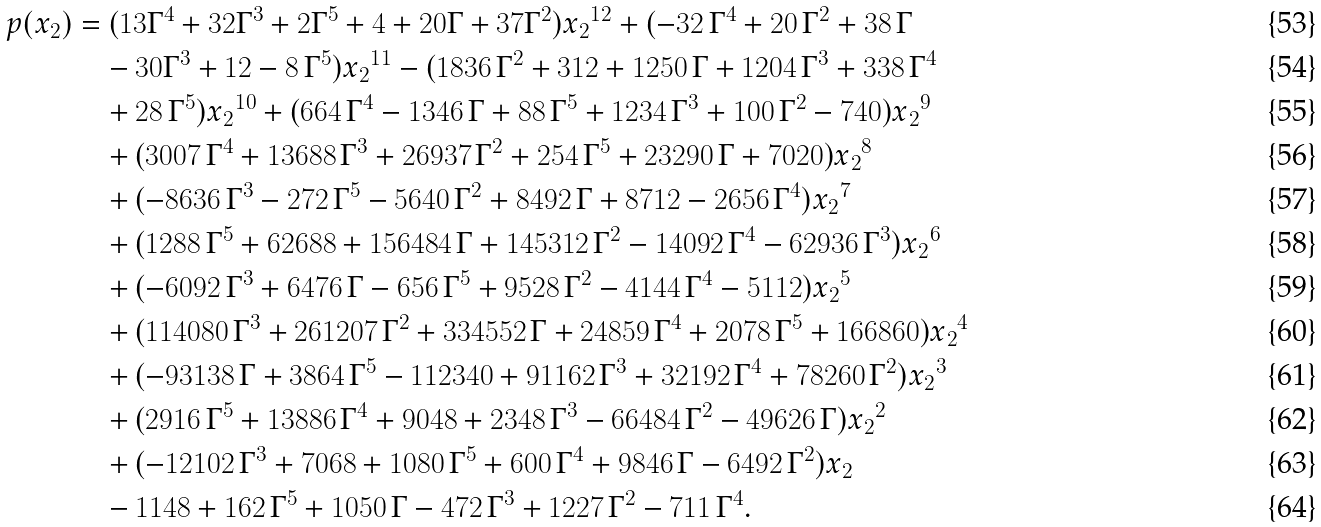Convert formula to latex. <formula><loc_0><loc_0><loc_500><loc_500>p ( x _ { 2 } ) & = ( 1 3 \Gamma ^ { 4 } + 3 2 \Gamma ^ { 3 } + 2 \Gamma ^ { 5 } + 4 + 2 0 \Gamma + 3 7 \Gamma ^ { 2 } ) { x _ { 2 } } ^ { 1 2 } + ( - 3 2 \, { \Gamma } ^ { 4 } + 2 0 \, { \Gamma } ^ { 2 } + 3 8 \, \Gamma \\ & \quad - 3 0 { \Gamma } ^ { 3 } + 1 2 - 8 \, { \Gamma } ^ { 5 } ) { x _ { 2 } } ^ { 1 1 } - ( 1 8 3 6 \, { \Gamma } ^ { 2 } + 3 1 2 + 1 2 5 0 \, \Gamma + 1 2 0 4 \, { \Gamma } ^ { 3 } + 3 3 8 \, { \Gamma } ^ { 4 } \\ & \quad + 2 8 \, { \Gamma } ^ { 5 } ) { x _ { 2 } } ^ { 1 0 } + ( 6 6 4 \, { \Gamma } ^ { 4 } - 1 3 4 6 \, \Gamma + 8 8 \, { \Gamma } ^ { 5 } + 1 2 3 4 \, { \Gamma } ^ { 3 } + 1 0 0 \, { \Gamma } ^ { 2 } - 7 4 0 ) { x _ { 2 } } ^ { 9 } \\ & \quad + ( 3 0 0 7 \, { \Gamma } ^ { 4 } + 1 3 6 8 8 \, { \Gamma } ^ { 3 } + 2 6 9 3 7 \, { \Gamma } ^ { 2 } + 2 5 4 \, { \Gamma } ^ { 5 } + 2 3 2 9 0 \, \Gamma + 7 0 2 0 ) { x _ { 2 } } ^ { 8 } \\ & \quad + ( - 8 6 3 6 \, { \Gamma } ^ { 3 } - 2 7 2 \, { \Gamma } ^ { 5 } - 5 6 4 0 \, { \Gamma } ^ { 2 } + 8 4 9 2 \, \Gamma + 8 7 1 2 - 2 6 5 6 \, { \Gamma } ^ { 4 } ) { x _ { 2 } } ^ { 7 } \\ & \quad + ( 1 2 8 8 \, { \Gamma } ^ { 5 } + 6 2 6 8 8 + 1 5 6 4 8 4 \, \Gamma + 1 4 5 3 1 2 \, { \Gamma } ^ { 2 } - 1 4 0 9 2 \, { \Gamma } ^ { 4 } - 6 2 9 3 6 \, { \Gamma } ^ { 3 } ) { x _ { 2 } } ^ { 6 } \\ & \quad + ( - 6 0 9 2 \, { \Gamma } ^ { 3 } + 6 4 7 6 \, \Gamma - 6 5 6 \, { \Gamma } ^ { 5 } + 9 5 2 8 \, { \Gamma } ^ { 2 } - 4 1 4 4 \, { \Gamma } ^ { 4 } - 5 1 1 2 ) { x _ { 2 } } ^ { 5 } \\ & \quad + ( 1 1 4 0 8 0 \, { \Gamma } ^ { 3 } + 2 6 1 2 0 7 \, { \Gamma } ^ { 2 } + 3 3 4 5 5 2 \, \Gamma + 2 4 8 5 9 \, { \Gamma } ^ { 4 } + 2 0 7 8 \, { \Gamma } ^ { 5 } + 1 6 6 8 6 0 ) { x _ { 2 } } ^ { 4 } \\ & \quad + ( - 9 3 1 3 8 \, \Gamma + 3 8 6 4 \, { \Gamma } ^ { 5 } - 1 1 2 3 4 0 + 9 1 1 6 2 \, { \Gamma } ^ { 3 } + 3 2 1 9 2 \, { \Gamma } ^ { 4 } + 7 8 2 6 0 \, { \Gamma } ^ { 2 } ) { x _ { 2 } } ^ { 3 } \\ & \quad + ( 2 9 1 6 \, { \Gamma } ^ { 5 } + 1 3 8 8 6 \, { \Gamma } ^ { 4 } + 9 0 4 8 + 2 3 4 8 \, { \Gamma } ^ { 3 } - 6 6 4 8 4 \, { \Gamma } ^ { 2 } - 4 9 6 2 6 \, \Gamma ) { x _ { 2 } } ^ { 2 } \\ & \quad + ( - 1 2 1 0 2 \, { \Gamma } ^ { 3 } + 7 0 6 8 + 1 0 8 0 \, { \Gamma } ^ { 5 } + 6 0 0 \, { \Gamma } ^ { 4 } + 9 8 4 6 \, \Gamma - 6 4 9 2 \, { \Gamma } ^ { 2 } ) { x _ { 2 } } \\ & \quad - 1 1 4 8 + 1 6 2 \, { \Gamma } ^ { 5 } + 1 0 5 0 \, \Gamma - 4 7 2 \, { \Gamma } ^ { 3 } + 1 2 2 7 \, { \Gamma } ^ { 2 } - 7 1 1 \, { \Gamma } ^ { 4 } .</formula> 